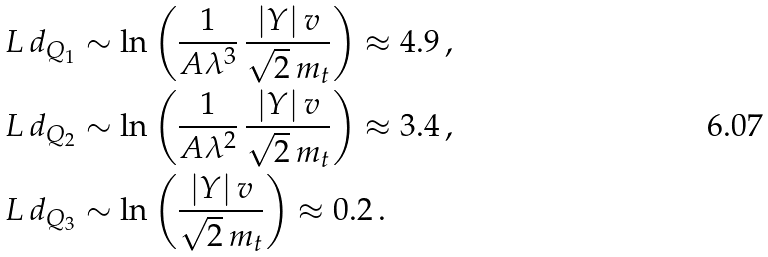Convert formula to latex. <formula><loc_0><loc_0><loc_500><loc_500>L \, d _ { Q _ { 1 } } & \sim \ln \left ( \frac { 1 } { A \lambda ^ { 3 } } \, \frac { | Y | \, v } { \sqrt { 2 } \, m _ { t } } \right ) \approx 4 . 9 \, , \\ L \, d _ { Q _ { 2 } } & \sim \ln \left ( \frac { 1 } { A \lambda ^ { 2 } } \, \frac { | Y | \, v } { \sqrt { 2 } \, m _ { t } } \right ) \approx 3 . 4 \, , \\ L \, d _ { Q _ { 3 } } & \sim \ln \left ( \frac { | Y | \, v } { \sqrt { 2 } \, m _ { t } } \right ) \approx 0 . 2 \, .</formula> 